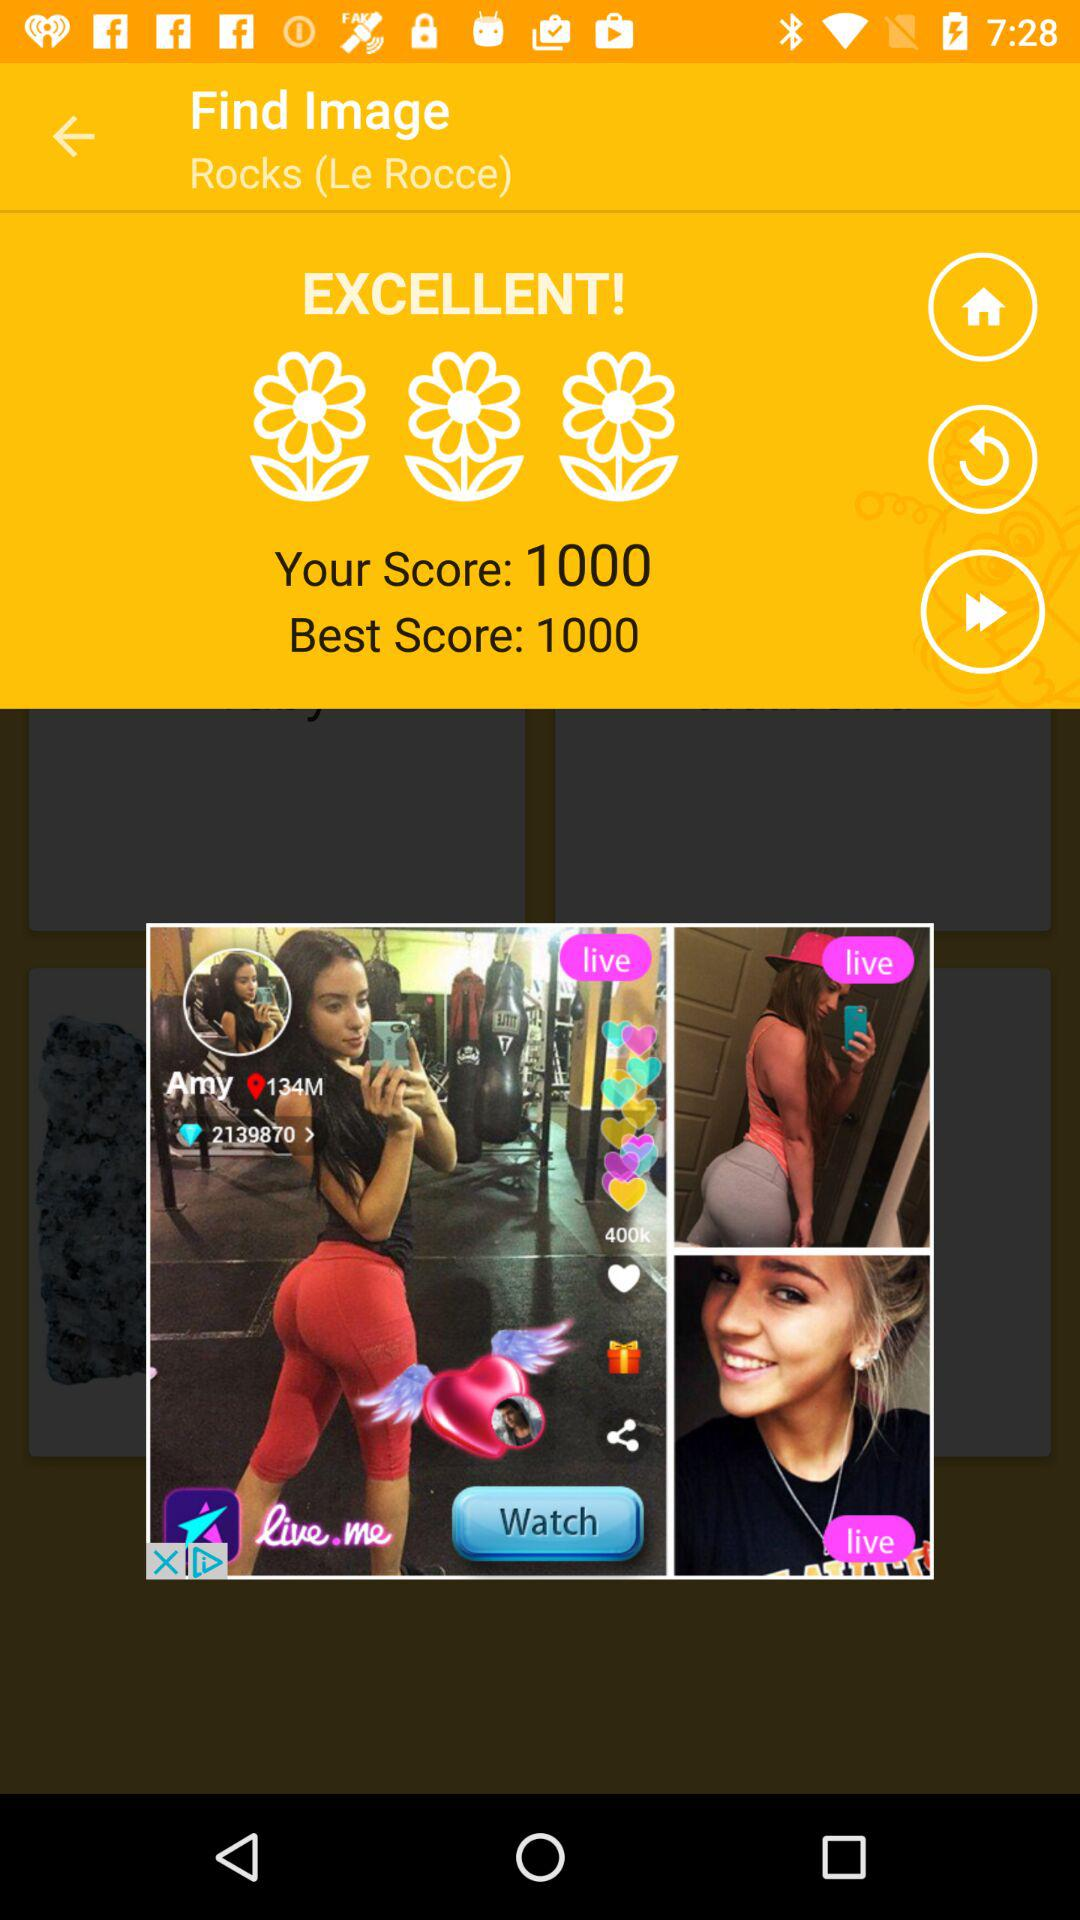What is the user's score? The score of the user is 1000. 